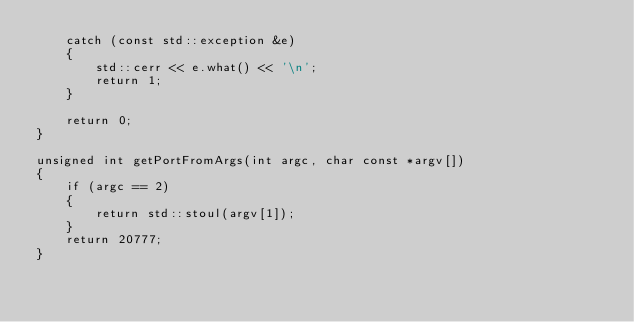<code> <loc_0><loc_0><loc_500><loc_500><_C++_>    catch (const std::exception &e)
    {
        std::cerr << e.what() << '\n';
        return 1;
    }

    return 0;
}

unsigned int getPortFromArgs(int argc, char const *argv[])
{
    if (argc == 2)
    {
        return std::stoul(argv[1]);
    }
    return 20777;
}
</code> 